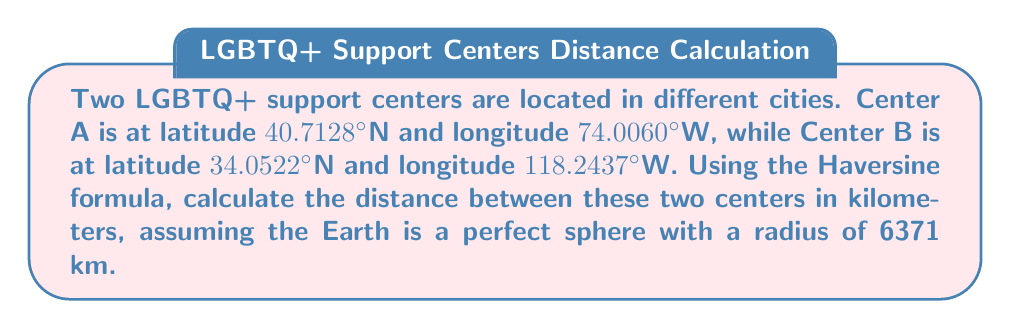Help me with this question. To calculate the distance between two points on Earth using latitude and longitude, we can use the Haversine formula:

1) First, convert the latitudes and longitudes from degrees to radians:
   $\text{lat}_1 = 40.7128° \times \frac{\pi}{180} = 0.7102$ rad
   $\text{lon}_1 = -74.0060° \times \frac{\pi}{180} = -1.2915$ rad
   $\text{lat}_2 = 34.0522° \times \frac{\pi}{180} = 0.5942$ rad
   $\text{lon}_2 = -118.2437° \times \frac{\pi}{180} = -2.0638$ rad

2) Calculate the differences:
   $\Delta\text{lat} = \text{lat}_2 - \text{lat}_1 = -0.1160$ rad
   $\Delta\text{lon} = \text{lon}_2 - \text{lon}_1 = -0.7723$ rad

3) Apply the Haversine formula:
   $$a = \sin^2(\frac{\Delta\text{lat}}{2}) + \cos(\text{lat}_1) \cos(\text{lat}_2) \sin^2(\frac{\Delta\text{lon}}{2})$$
   $$a = \sin^2(-0.0580) + \cos(0.7102) \cos(0.5942) \sin^2(-0.3862)$$
   $$a = 0.1974$$

4) Calculate the central angle:
   $$c = 2 \arctan2(\sqrt{a}, \sqrt{1-a}) = 0.9168$$

5) Calculate the distance:
   $$d = R \times c$$
   Where $R$ is the radius of Earth (6371 km)
   $$d = 6371 \times 0.9168 = 5840.9 \text{ km}$$

Therefore, the distance between the two LGBTQ+ support centers is approximately 5840.9 km.
Answer: 5840.9 km 